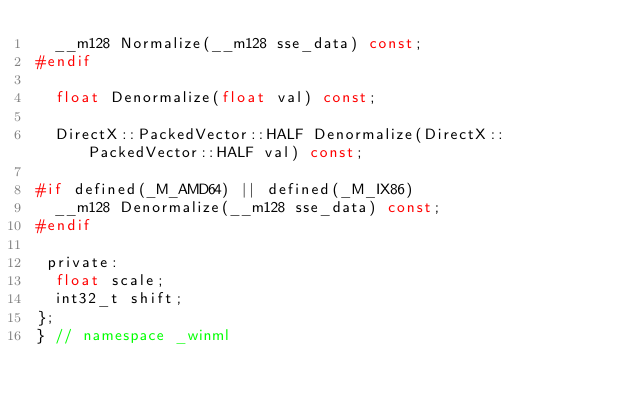Convert code to text. <code><loc_0><loc_0><loc_500><loc_500><_C_>  __m128 Normalize(__m128 sse_data) const;
#endif

  float Denormalize(float val) const;

  DirectX::PackedVector::HALF Denormalize(DirectX::PackedVector::HALF val) const;

#if defined(_M_AMD64) || defined(_M_IX86)
  __m128 Denormalize(__m128 sse_data) const;
#endif

 private:
  float scale;
  int32_t shift;
};
} // namespace _winml</code> 